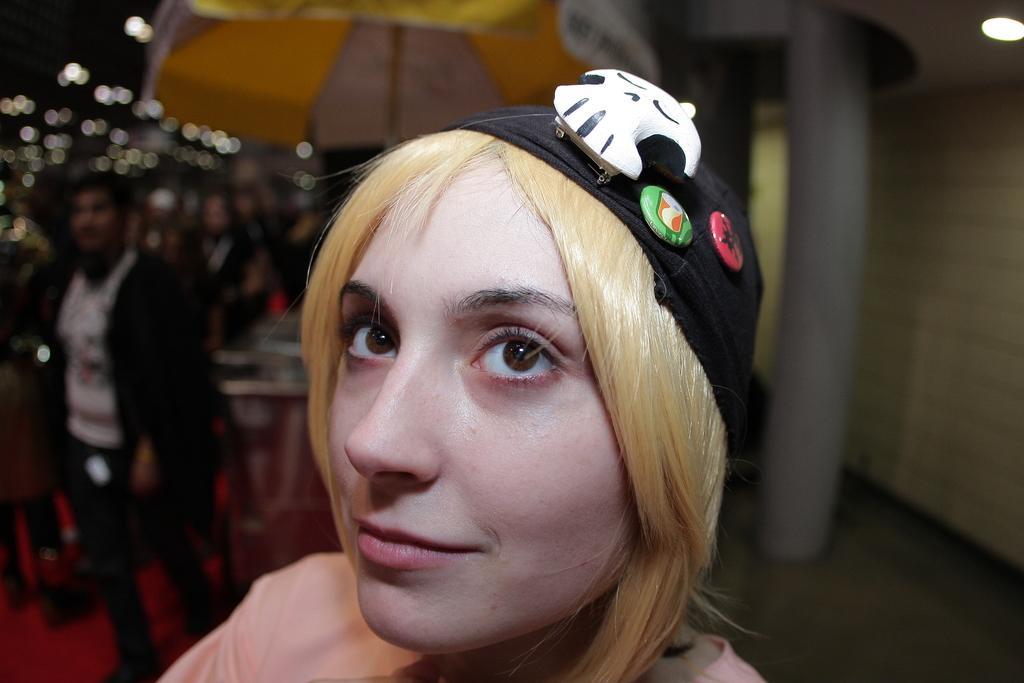Describe this image in one or two sentences. In this image I can see a person standing. The person is wearing light pink color shirt and black color cap, background I can see the other person standing and few lights. 